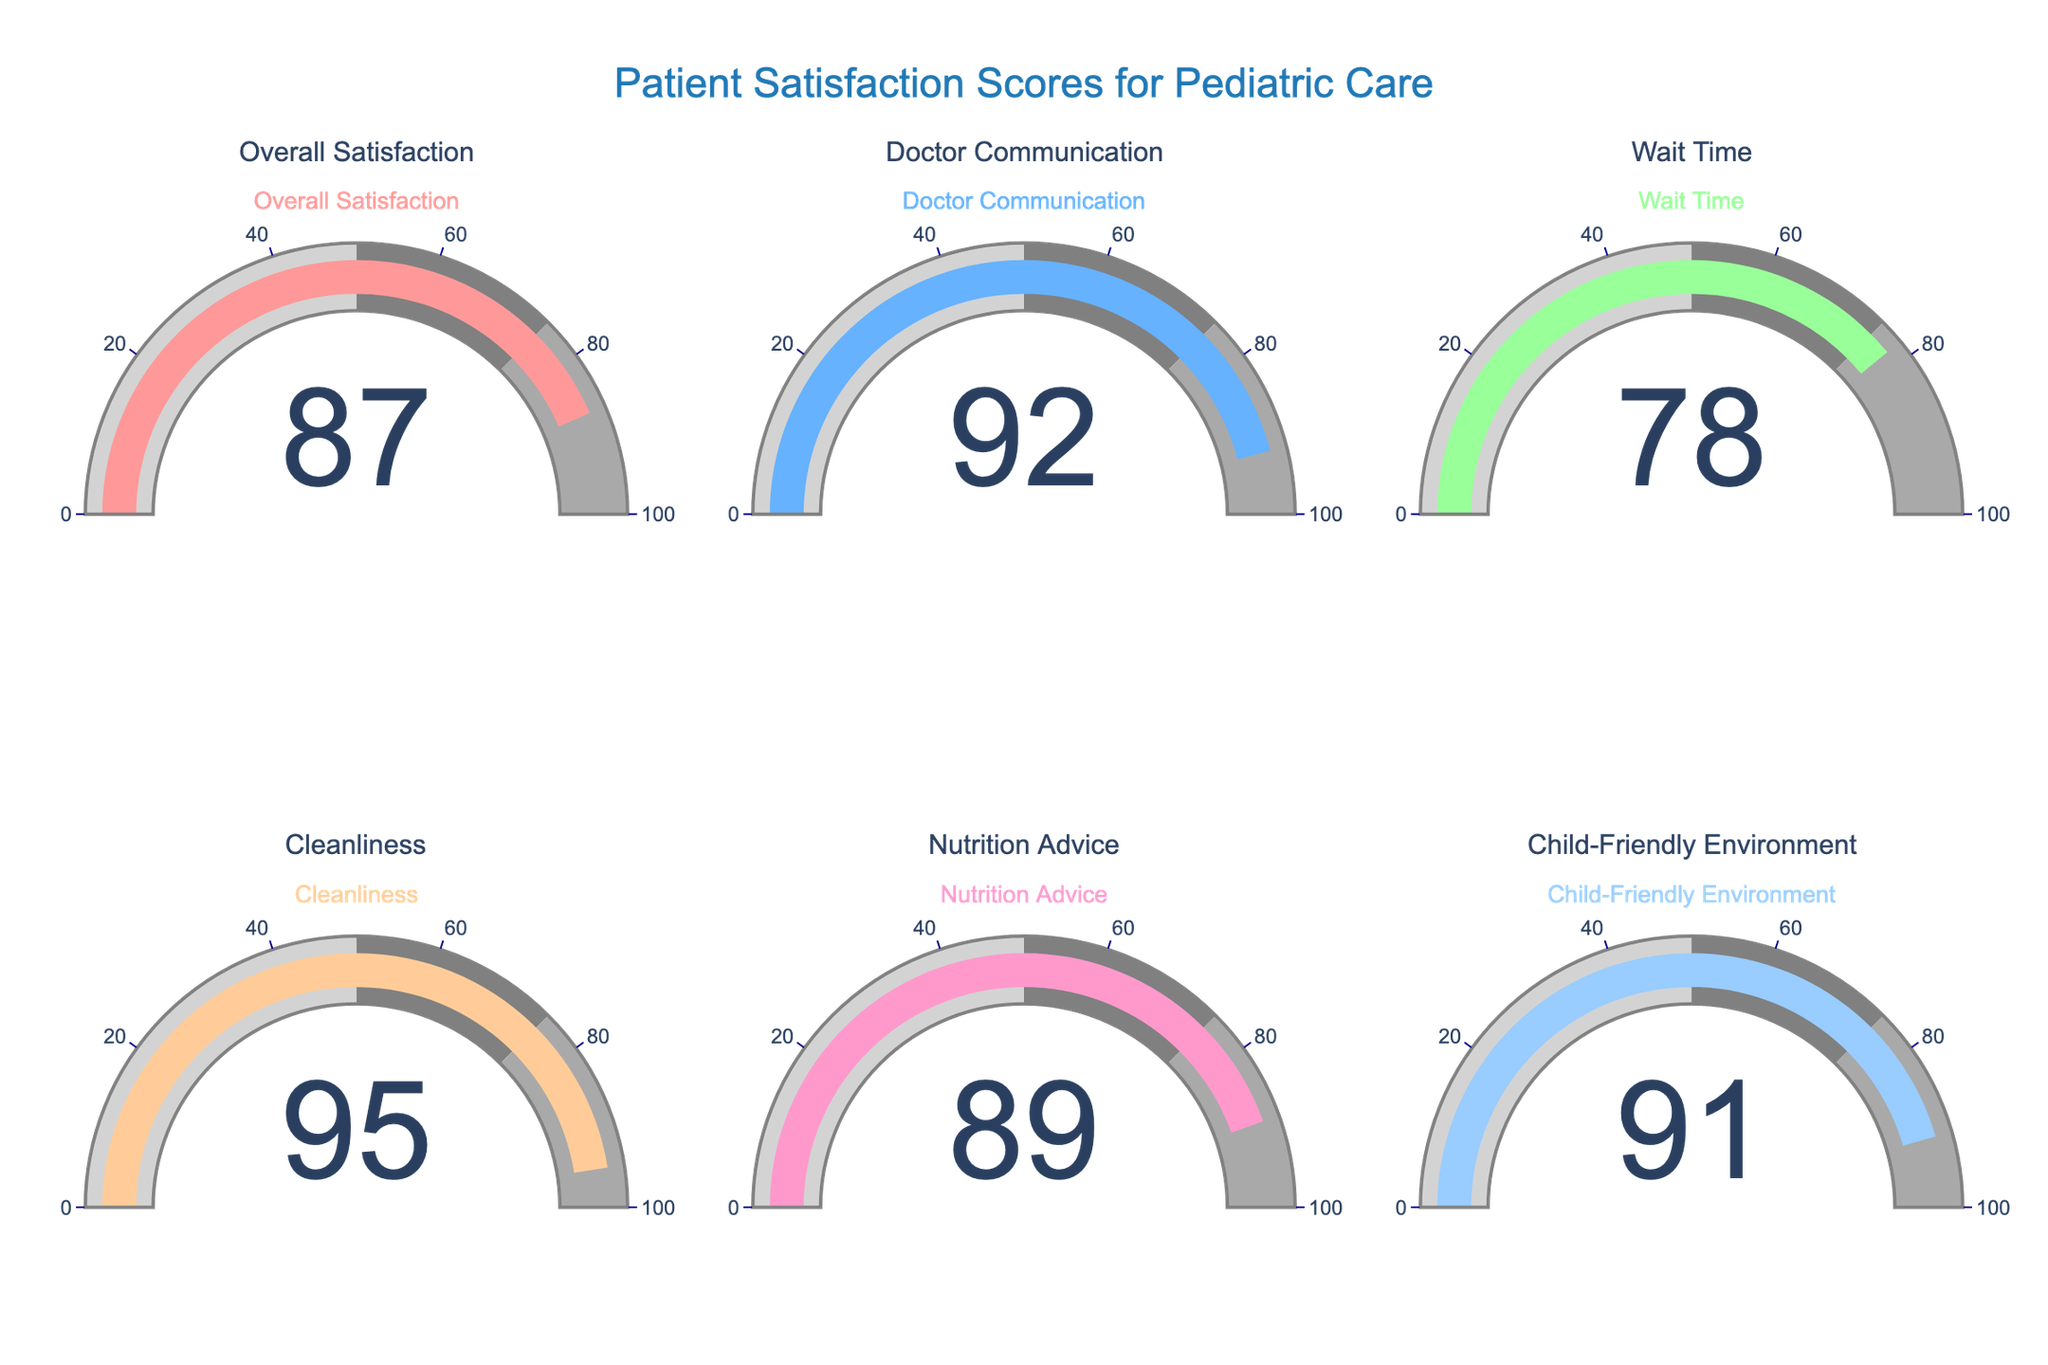What's the title of the figure? The title is usually placed at the top-center of the figure and it summarizes the content. In this case, it is located at the top of the gauge chart.
Answer: Patient Satisfaction Scores for Pediatric Care How many categories are displayed in the figure? By looking at the gauge charts, you can count the number of different sections, each labeled with a category name.
Answer: 6 Which category has the highest satisfaction score? Check each gauge to find the score and identify which one has the highest value.
Answer: Cleanliness Which category has the lowest satisfaction score? Check each gauge to find the score and identify which one has the lowest value.
Answer: Wait Time What is the satisfaction score for Doctor Communication? Locate the gauge labeled "Doctor Communication" and read the score displayed on it.
Answer: 92 Which categories have a satisfaction score greater than 90? Identify the gauges with values over 90 and list their respective categories.
Answer: Doctor Communication, Cleanliness, Child-Friendly Environment What is the average satisfaction score for all categories? Add all the scores together and then divide by the number of categories (87 + 92 + 78 + 95 + 89 + 91) / 6.
Answer: 88.67 How much higher is the satisfaction score for Nutrition Advice compared to Wait Time? Subtract the score of Wait Time from the score of Nutrition Advice (89 - 78).
Answer: 11 Which category is closest to the overall satisfaction score? Compare the score of "Overall Satisfaction" with the scores of all other categories and find the one with the smallest difference from 87.
Answer: Nutrition Advice What is the difference between the highest and lowest satisfaction scores? Subtract the lowest score (Wait Time) from the highest score (Cleanliness) (95 - 78).
Answer: 17 